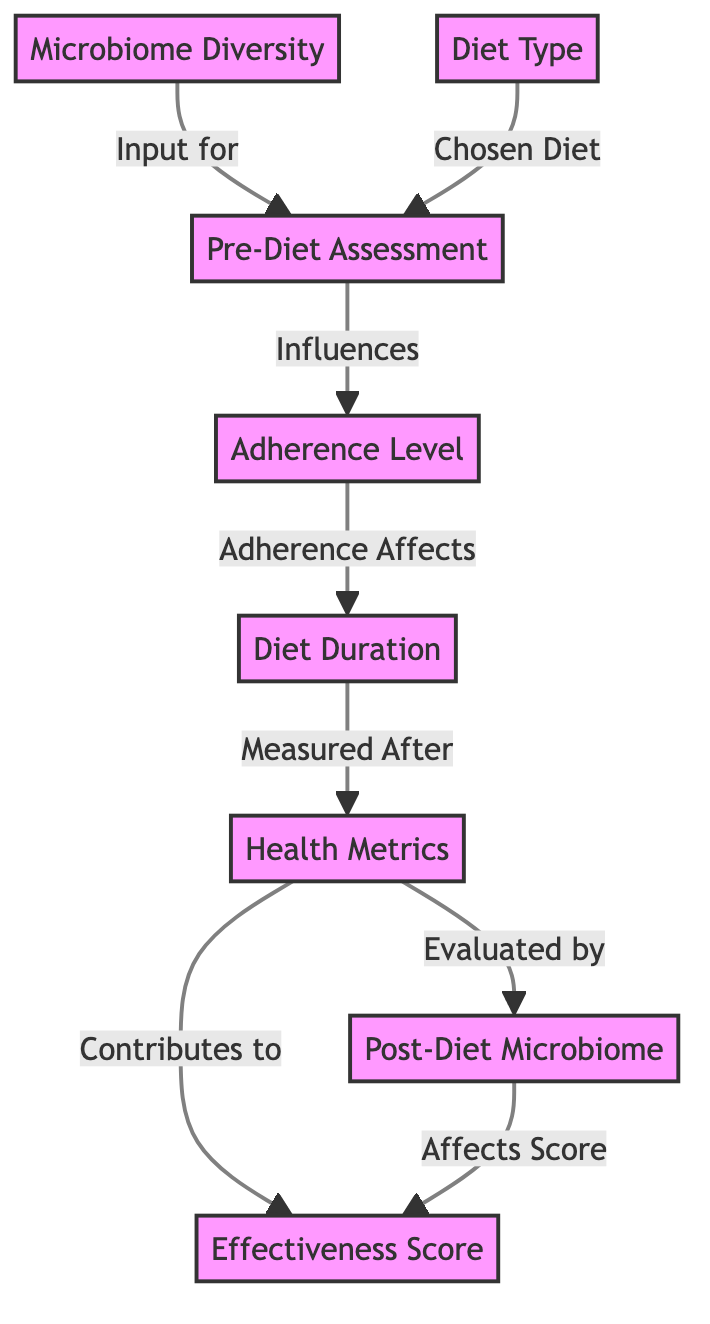What is the starting node in the diagram? The starting node is Microbiome Diversity, which is the first node that other nodes depend on for their input.
Answer: Microbiome Diversity How many nodes are present in the diagram? By counting all the distinct labeled nodes, we can see there are eight nodes in total.
Answer: Eight Which node influences the Adherence Level? The Pre-Diet Assessment node has a direct influence on the Adherence Level, showing that the initial assessment affects how well the diet is followed.
Answer: Pre-Diet Assessment What node is evaluated by Health Metrics? The Post-Diet Microbiome node is evaluated by Health Metrics, indicating that the health measurements are based on the microbiome after the diet has been completed.
Answer: Post-Diet Microbiome How does Diet Duration affect the effectiveness score? The Adherence Level impacts the Diet Duration, which in turn indirectly contributes to the Effectiveness Score by measuring how long the diet was followed effectively.
Answer: Indirectly through Adherence Level What is the relationship between Health Metrics and Effectiveness Score? Health Metrics contribute directly to the Effectiveness Score, showing that the measurements of health after the diet affect how effective the diet was overall.
Answer: Contributes to Which node represents the final output of the analysis? The Effectiveness Score serves as the final output, representing the overall assessment of the diet’s impact after considering all prior nodes.
Answer: Effectiveness Score What is one of the primary inputs for the Pre-Diet Assessment? One of the primary inputs is the Microbiome Diversity, highlighting the importance of the microbiome in initial dietary considerations.
Answer: Microbiome Diversity Which two nodes are connected directly to Health Metrics? The Diet Duration and the Post-Diet Microbiome both connect directly to Health Metrics, indicating their role in evaluating the health outcomes of the diet.
Answer: Diet Duration and Post-Diet Microbiome 